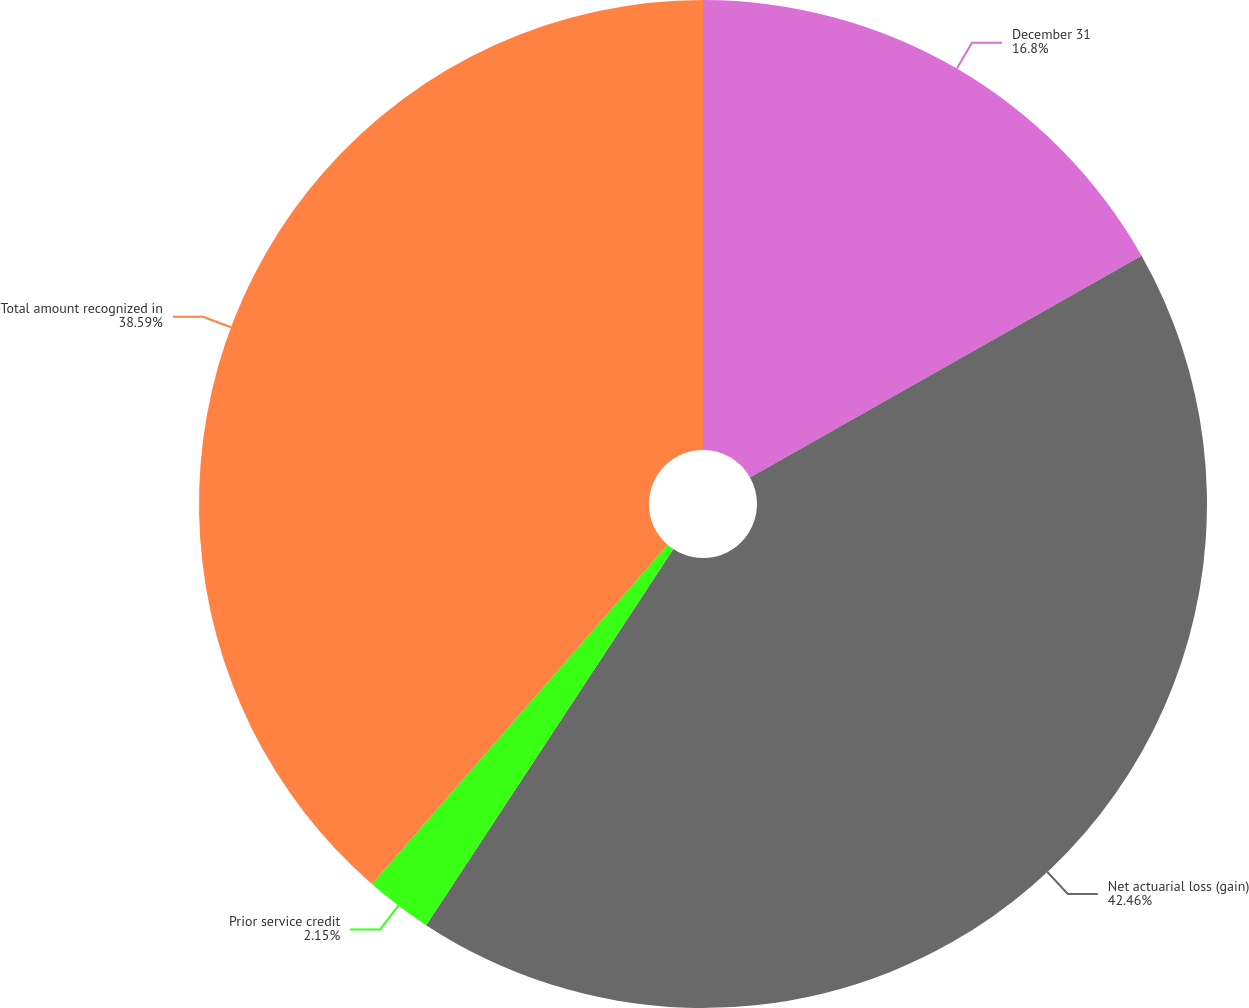Convert chart. <chart><loc_0><loc_0><loc_500><loc_500><pie_chart><fcel>December 31<fcel>Net actuarial loss (gain)<fcel>Prior service credit<fcel>Total amount recognized in<nl><fcel>16.8%<fcel>42.45%<fcel>2.15%<fcel>38.59%<nl></chart> 